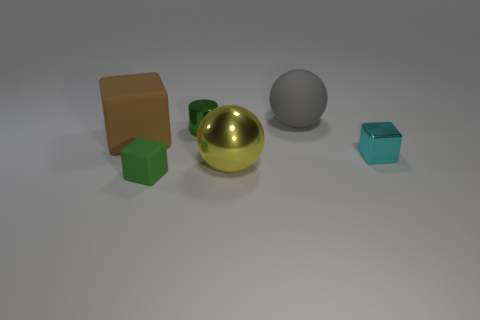Do the tiny block on the left side of the gray sphere and the tiny metallic cylinder have the same color?
Your answer should be compact. Yes. There is a object on the right side of the sphere that is behind the large sphere that is in front of the gray object; what is its shape?
Give a very brief answer. Cube. What number of things are either blocks in front of the brown matte cube or blocks that are on the left side of the tiny matte thing?
Your response must be concise. 3. There is a metallic cube; are there any balls in front of it?
Give a very brief answer. Yes. How many objects are either blocks that are on the right side of the big brown matte thing or large brown cubes?
Make the answer very short. 3. How many green things are either small rubber objects or tiny objects?
Your response must be concise. 2. What number of other things are the same color as the large shiny ball?
Give a very brief answer. 0. Are there fewer large yellow shiny things that are to the right of the small metal block than large yellow matte cylinders?
Your answer should be compact. No. The ball in front of the tiny green metallic thing behind the small cube that is on the right side of the green metallic cylinder is what color?
Make the answer very short. Yellow. Are there any other things that are made of the same material as the cylinder?
Provide a succinct answer. Yes. 